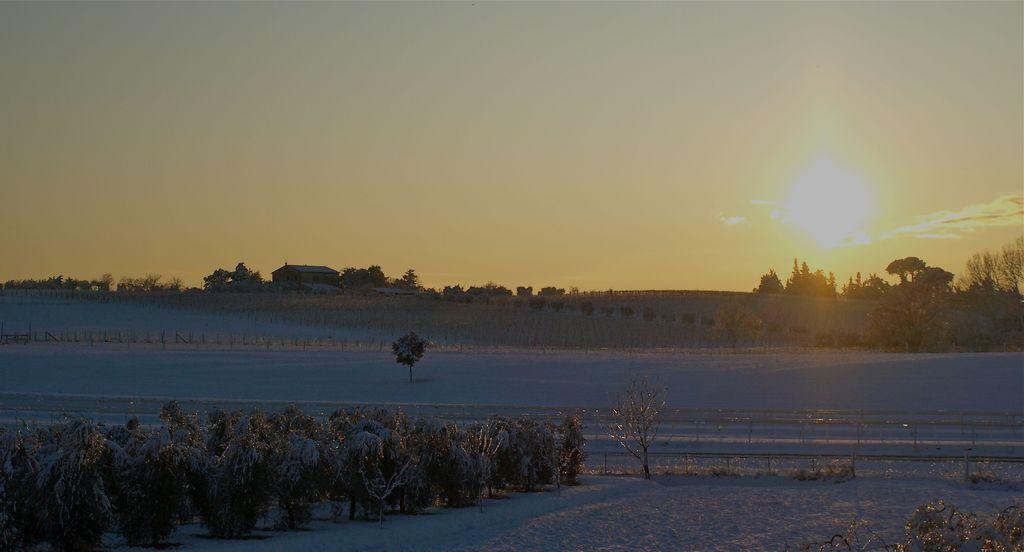Can you describe this image briefly? In this image I can see there are trees and a snow. At the side there is a fence and buildings. And at the top there is a sky. 